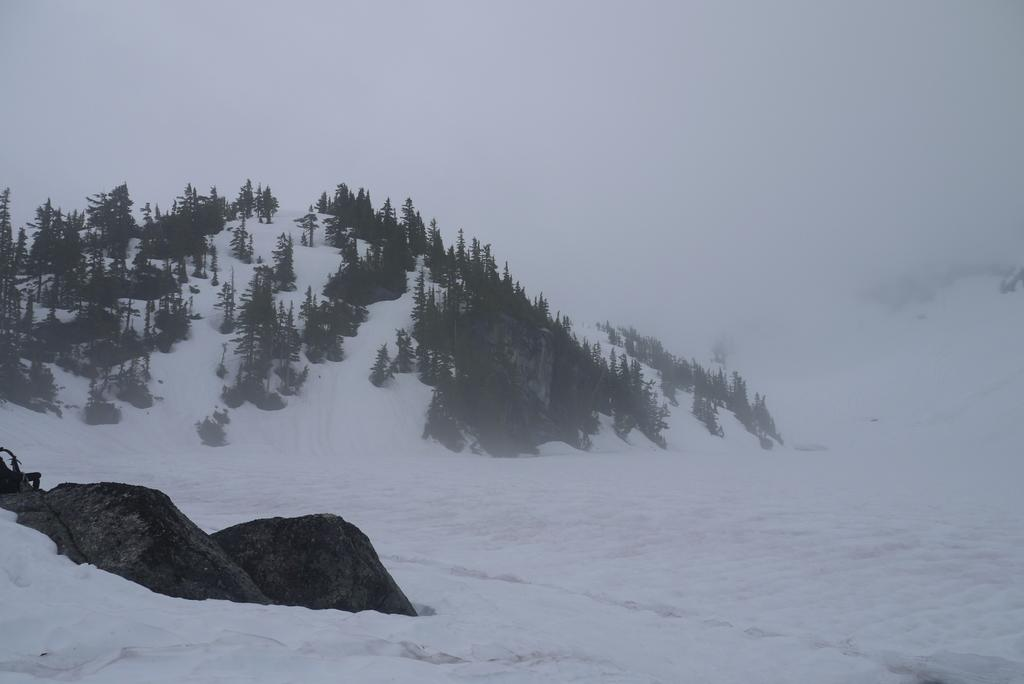What type of vegetation is present in the image? There are trees in the image. What other natural elements can be seen in the image? There are rocks in the image. What is the weather or season suggested by the image? There is snow visible in the image, which suggests a cold or wintery environment. What type of drug is being used by the person in the image? There is no person present in the image, and therefore no drug use can be observed. 